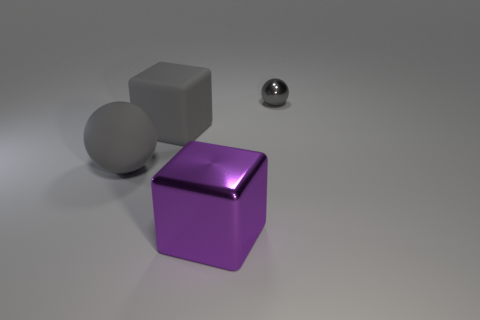Subtract 2 blocks. How many blocks are left? 0 Subtract all purple cubes. Subtract all purple balls. How many cubes are left? 1 Subtract all cyan spheres. How many purple cubes are left? 1 Subtract all gray rubber objects. Subtract all big matte blocks. How many objects are left? 1 Add 1 tiny objects. How many tiny objects are left? 2 Add 1 large blue metallic things. How many large blue metallic things exist? 1 Add 3 gray rubber blocks. How many objects exist? 7 Subtract all purple blocks. How many blocks are left? 1 Subtract 0 gray cylinders. How many objects are left? 4 